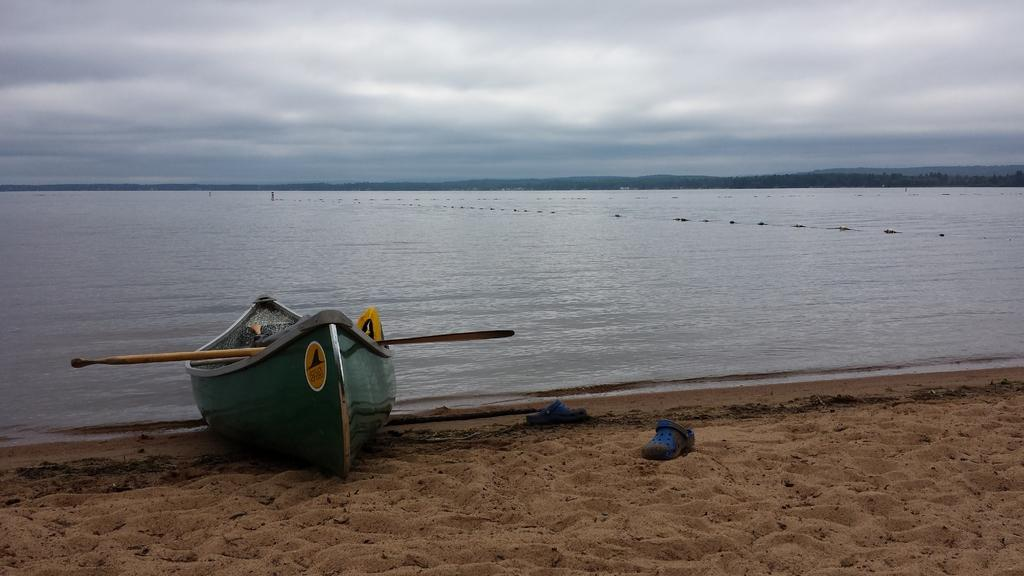What is in the foreground of the image? There is sand, chapels, and a boat in the foreground of the image. Can you describe the water in the image? There is water visible in the background of the image. What type of vegetation can be seen in the background of the image? There is greenery in the background of the image. What else is visible in the background of the image? The sky is visible in the background of the image. How many taxes are being paid by the boat in the image? There is no indication of taxes being paid in the image, as it features a boat, sand, chapels, water, greenery, and the sky. Can you see any snakes in the image? There are no snakes present in the image. 